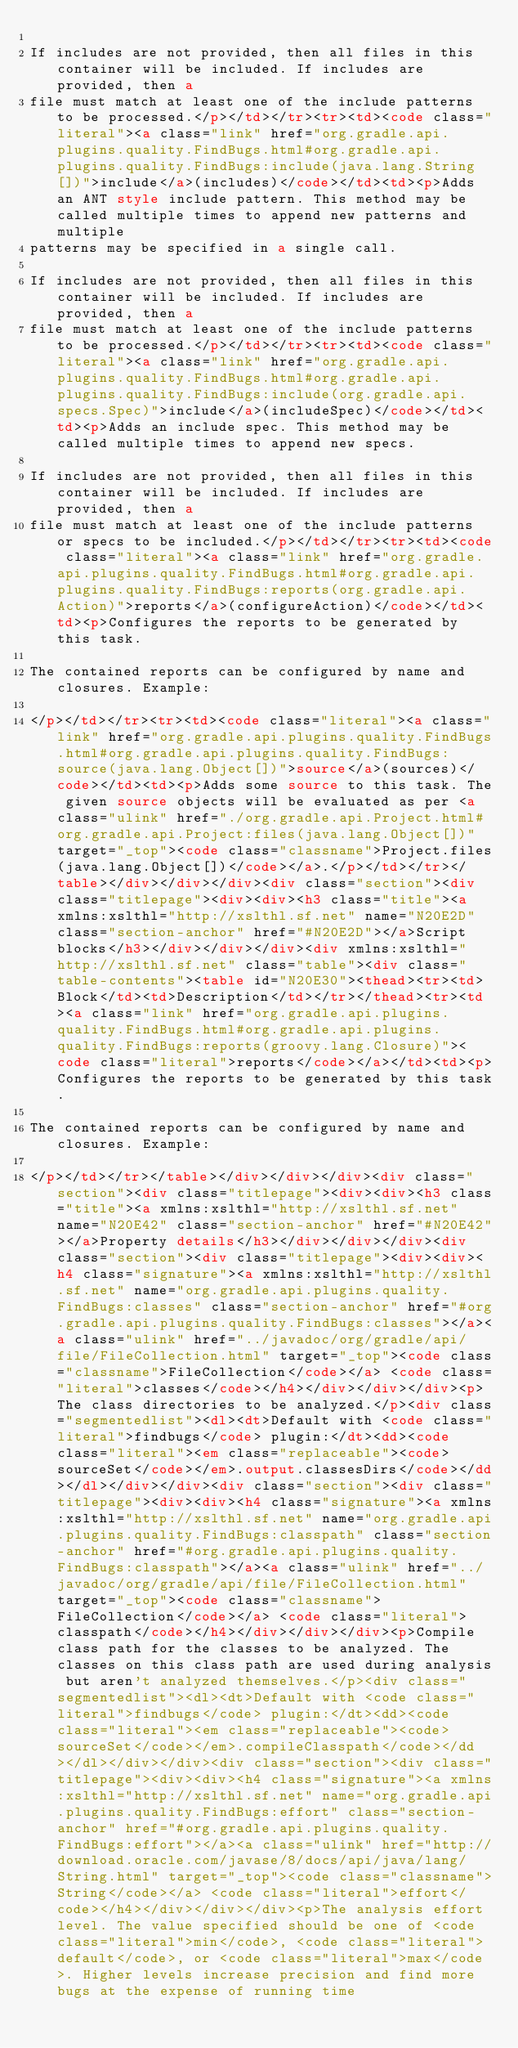Convert code to text. <code><loc_0><loc_0><loc_500><loc_500><_HTML_>
If includes are not provided, then all files in this container will be included. If includes are provided, then a
file must match at least one of the include patterns to be processed.</p></td></tr><tr><td><code class="literal"><a class="link" href="org.gradle.api.plugins.quality.FindBugs.html#org.gradle.api.plugins.quality.FindBugs:include(java.lang.String[])">include</a>(includes)</code></td><td><p>Adds an ANT style include pattern. This method may be called multiple times to append new patterns and multiple
patterns may be specified in a single call.

If includes are not provided, then all files in this container will be included. If includes are provided, then a
file must match at least one of the include patterns to be processed.</p></td></tr><tr><td><code class="literal"><a class="link" href="org.gradle.api.plugins.quality.FindBugs.html#org.gradle.api.plugins.quality.FindBugs:include(org.gradle.api.specs.Spec)">include</a>(includeSpec)</code></td><td><p>Adds an include spec. This method may be called multiple times to append new specs.

If includes are not provided, then all files in this container will be included. If includes are provided, then a
file must match at least one of the include patterns or specs to be included.</p></td></tr><tr><td><code class="literal"><a class="link" href="org.gradle.api.plugins.quality.FindBugs.html#org.gradle.api.plugins.quality.FindBugs:reports(org.gradle.api.Action)">reports</a>(configureAction)</code></td><td><p>Configures the reports to be generated by this task.

The contained reports can be configured by name and closures. Example:

</p></td></tr><tr><td><code class="literal"><a class="link" href="org.gradle.api.plugins.quality.FindBugs.html#org.gradle.api.plugins.quality.FindBugs:source(java.lang.Object[])">source</a>(sources)</code></td><td><p>Adds some source to this task. The given source objects will be evaluated as per <a class="ulink" href="./org.gradle.api.Project.html#org.gradle.api.Project:files(java.lang.Object[])" target="_top"><code class="classname">Project.files(java.lang.Object[])</code></a>.</p></td></tr></table></div></div></div><div class="section"><div class="titlepage"><div><div><h3 class="title"><a xmlns:xslthl="http://xslthl.sf.net" name="N20E2D" class="section-anchor" href="#N20E2D"></a>Script blocks</h3></div></div></div><div xmlns:xslthl="http://xslthl.sf.net" class="table"><div class="table-contents"><table id="N20E30"><thead><tr><td>Block</td><td>Description</td></tr></thead><tr><td><a class="link" href="org.gradle.api.plugins.quality.FindBugs.html#org.gradle.api.plugins.quality.FindBugs:reports(groovy.lang.Closure)"><code class="literal">reports</code></a></td><td><p>Configures the reports to be generated by this task.

The contained reports can be configured by name and closures. Example:

</p></td></tr></table></div></div></div><div class="section"><div class="titlepage"><div><div><h3 class="title"><a xmlns:xslthl="http://xslthl.sf.net" name="N20E42" class="section-anchor" href="#N20E42"></a>Property details</h3></div></div></div><div class="section"><div class="titlepage"><div><div><h4 class="signature"><a xmlns:xslthl="http://xslthl.sf.net" name="org.gradle.api.plugins.quality.FindBugs:classes" class="section-anchor" href="#org.gradle.api.plugins.quality.FindBugs:classes"></a><a class="ulink" href="../javadoc/org/gradle/api/file/FileCollection.html" target="_top"><code class="classname">FileCollection</code></a> <code class="literal">classes</code></h4></div></div></div><p>The class directories to be analyzed.</p><div class="segmentedlist"><dl><dt>Default with <code class="literal">findbugs</code> plugin:</dt><dd><code class="literal"><em class="replaceable"><code>sourceSet</code></em>.output.classesDirs</code></dd></dl></div></div><div class="section"><div class="titlepage"><div><div><h4 class="signature"><a xmlns:xslthl="http://xslthl.sf.net" name="org.gradle.api.plugins.quality.FindBugs:classpath" class="section-anchor" href="#org.gradle.api.plugins.quality.FindBugs:classpath"></a><a class="ulink" href="../javadoc/org/gradle/api/file/FileCollection.html" target="_top"><code class="classname">FileCollection</code></a> <code class="literal">classpath</code></h4></div></div></div><p>Compile class path for the classes to be analyzed. The classes on this class path are used during analysis but aren't analyzed themselves.</p><div class="segmentedlist"><dl><dt>Default with <code class="literal">findbugs</code> plugin:</dt><dd><code class="literal"><em class="replaceable"><code>sourceSet</code></em>.compileClasspath</code></dd></dl></div></div><div class="section"><div class="titlepage"><div><div><h4 class="signature"><a xmlns:xslthl="http://xslthl.sf.net" name="org.gradle.api.plugins.quality.FindBugs:effort" class="section-anchor" href="#org.gradle.api.plugins.quality.FindBugs:effort"></a><a class="ulink" href="http://download.oracle.com/javase/8/docs/api/java/lang/String.html" target="_top"><code class="classname">String</code></a> <code class="literal">effort</code></h4></div></div></div><p>The analysis effort level. The value specified should be one of <code class="literal">min</code>, <code class="literal">default</code>, or <code class="literal">max</code>. Higher levels increase precision and find more bugs at the expense of running time</code> 